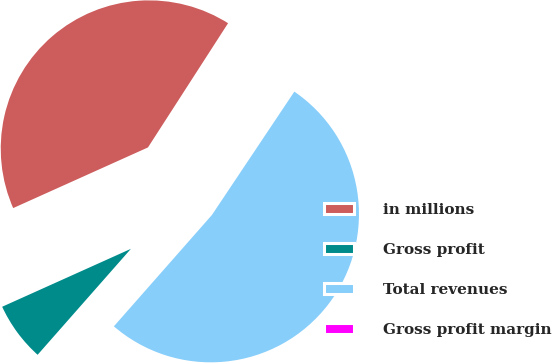<chart> <loc_0><loc_0><loc_500><loc_500><pie_chart><fcel>in millions<fcel>Gross profit<fcel>Total revenues<fcel>Gross profit margin<nl><fcel>40.84%<fcel>6.78%<fcel>52.11%<fcel>0.26%<nl></chart> 